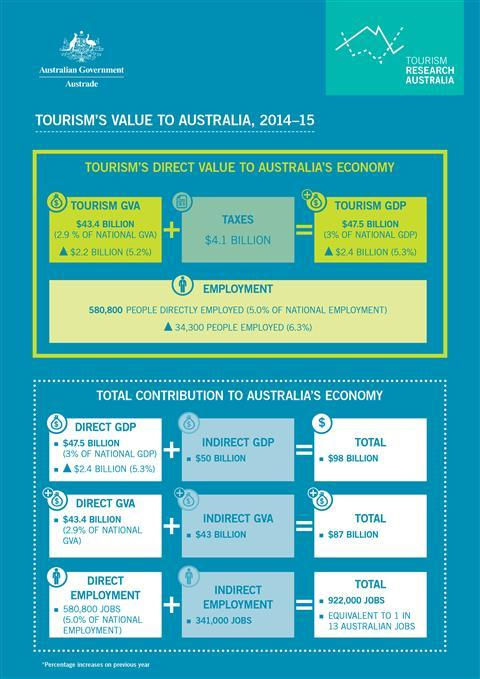Specify some key components in this picture. The total of tourism GVA and taxes is 47.5 billion. The total of Direct GVA and Indirect GVA is $87 billion. The total of direct GDP and indirect GDP is 98 billion. 97% of the National GDP is not Direct GDP. The value of Tourism GVA is 43.4 billion. 